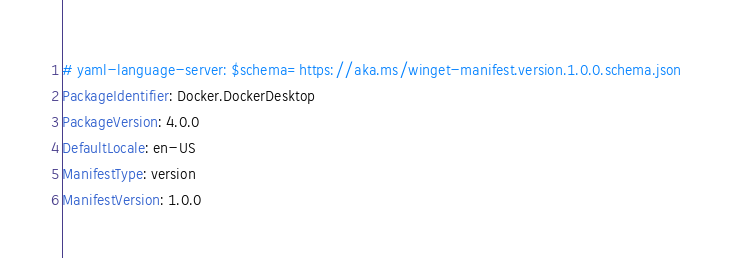<code> <loc_0><loc_0><loc_500><loc_500><_YAML_># yaml-language-server: $schema=https://aka.ms/winget-manifest.version.1.0.0.schema.json
PackageIdentifier: Docker.DockerDesktop
PackageVersion: 4.0.0
DefaultLocale: en-US
ManifestType: version
ManifestVersion: 1.0.0

</code> 